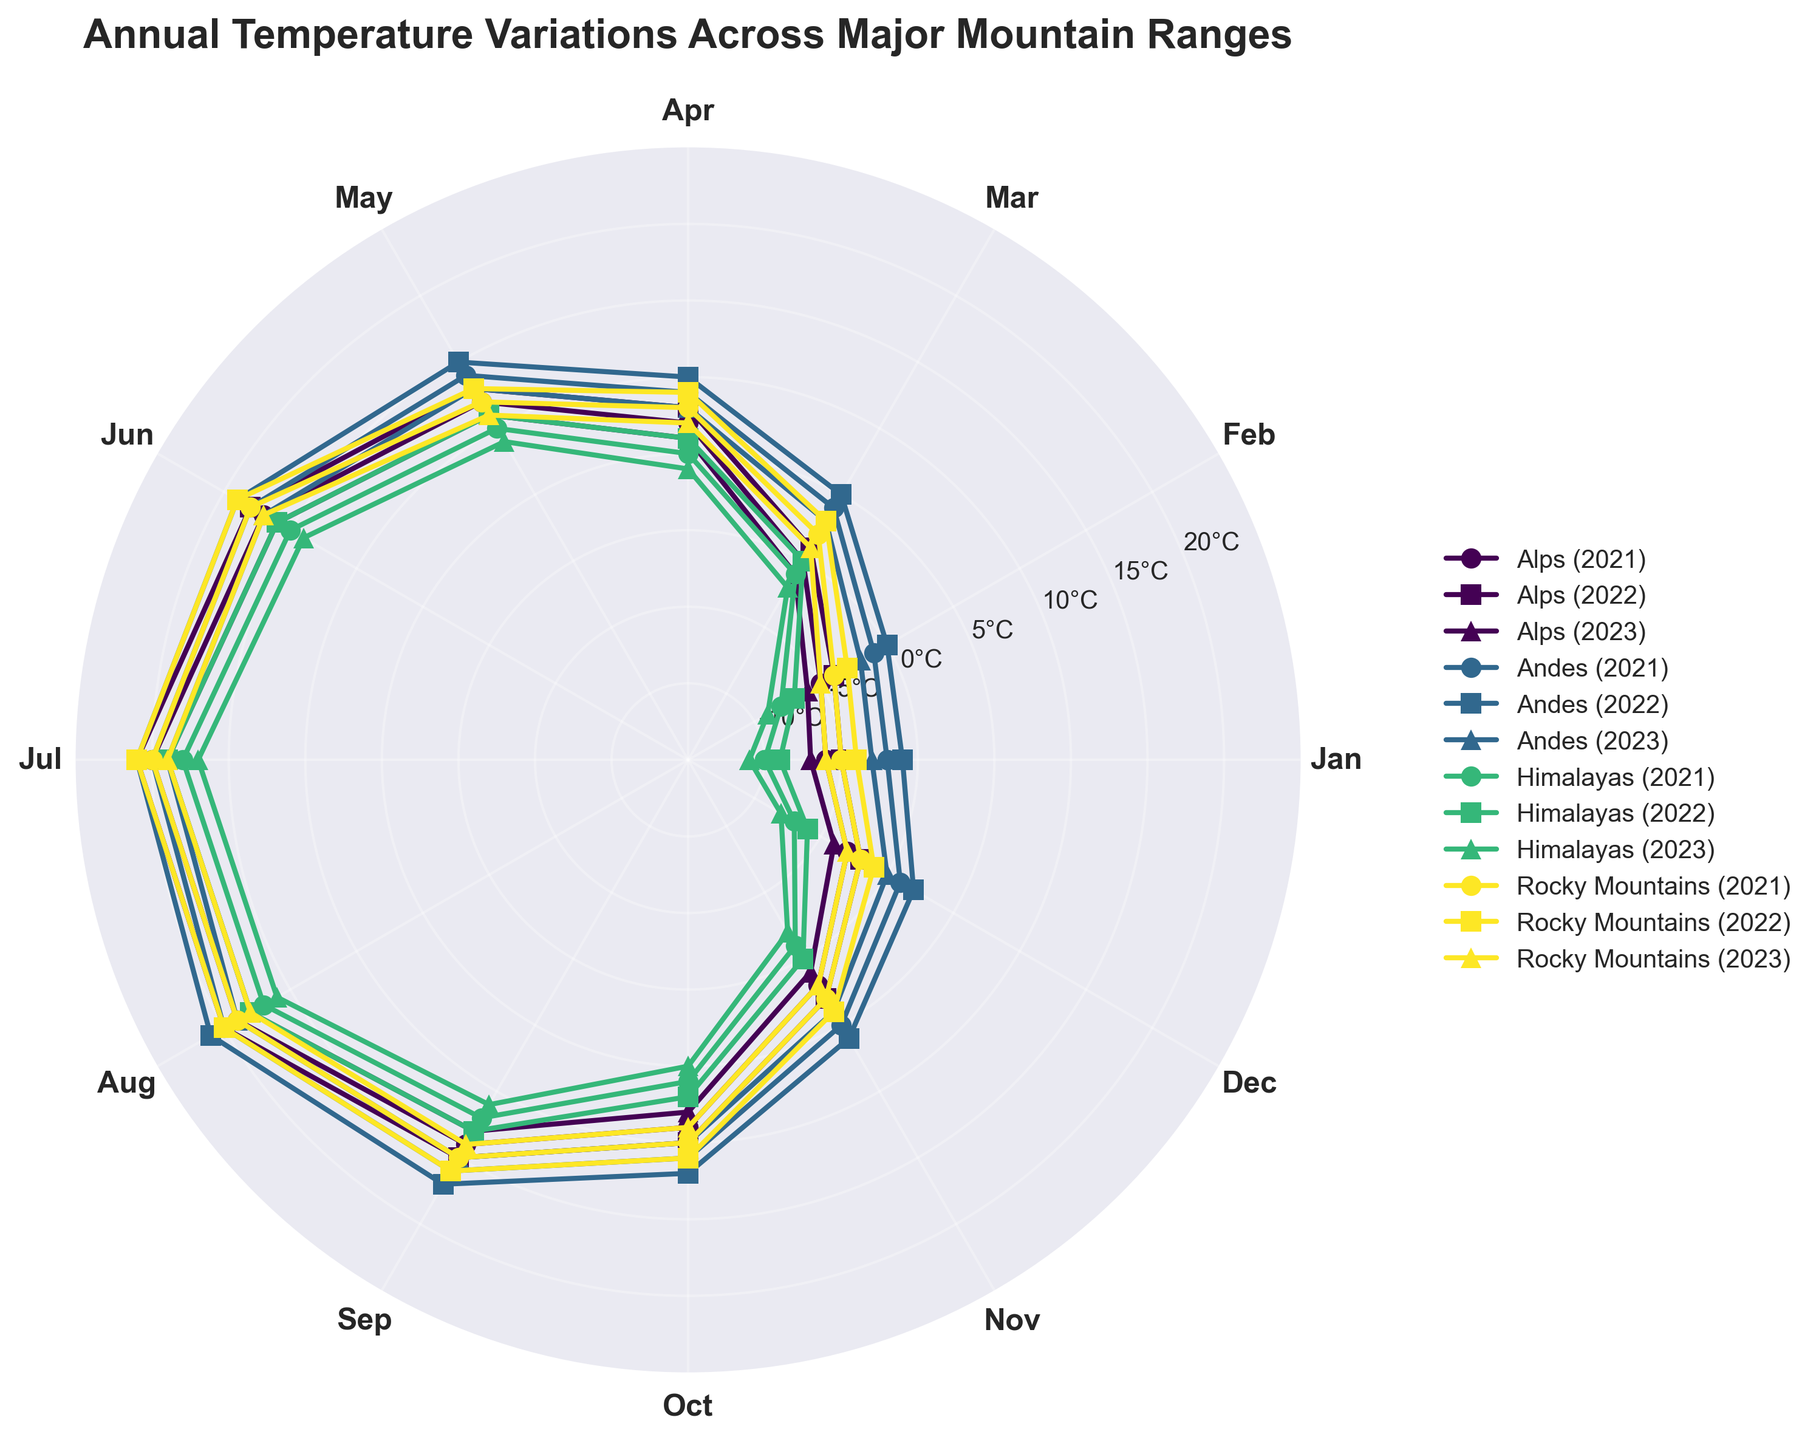what is the title of the figure? The title of the figure is found at the top and reads: "Annual Temperature Variations Across Major Mountain Ranges."
Answer: Annual Temperature Variations Across Major Mountain Ranges How many mountain ranges are represented in the figure? Count the number of unique legends corresponding to different mountain ranges. The mountain ranges are listed as Rocky Mountains, Himalayas, Andes, and Alps.
Answer: 4 What is the temperature range shown on the radial axis? The radial axis displays a range of temperatures from -15°C to 25°C, as indicated by the labels on the axis.
Answer: -15°C to 25°C Which mountain range shows the highest temperature in July of any year? Examine the peaks in the month of July across different mountain ranges. The highest value reaches 21°C for the Andes in July 2022.
Answer: Andes Which year does the Rocky Mountains have the lowest temperature in January? Compare the temperatures in January for the Rocky Mountains across different years. The lowest January temperature is -6°C in the year 2023.
Answer: 2023 What is the difference in average July temperatures between the Alps and the Rocky Mountains in 2021? Find the July temperatures for both mountain ranges in 2021. The Alps have 20°C and the Rocky Mountains have 20°C. Calculate the difference: 20°C - 20°C = 0°C.
Answer: 0°C Which mountain range shows the most significant annual temperature variation in 2022? Assess the temperature range (highest minus lowest) for each mountain range in 2022. The Rocky Mountains range from -3°C to 21°C, a difference of 24°C. This is the most significant variation.
Answer: Rocky Mountains During which month do the Himalayas experience temperatures above 15°C consistently over all three years? Check the Himalayas' temperature for each month across the years. Only in June, July, and August do temperatures exceed 15°C consistently.
Answer: July Does any mountain range have higher average temperatures in December than April in any year? Examine the temperatures in December and April for each mountain range and each year. None of the ranges have higher temperatures in December compared to April in any year.
Answer: No Which mountain range showed the smallest temperature decrease from November to December in 2021? Compare the temperature differences between November and December for each mountain range in 2021. The Andes show a decrease from 5°C to 1°C, a difference of 4°C, which is the smallest.
Answer: Andes 